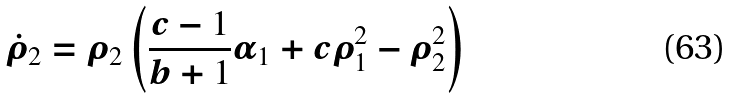<formula> <loc_0><loc_0><loc_500><loc_500>\dot { \rho } _ { 2 } = \rho _ { 2 } \left ( \frac { c - 1 } { b + 1 } \alpha _ { 1 } + c \rho _ { 1 } ^ { 2 } - \rho _ { 2 } ^ { 2 } \right )</formula> 